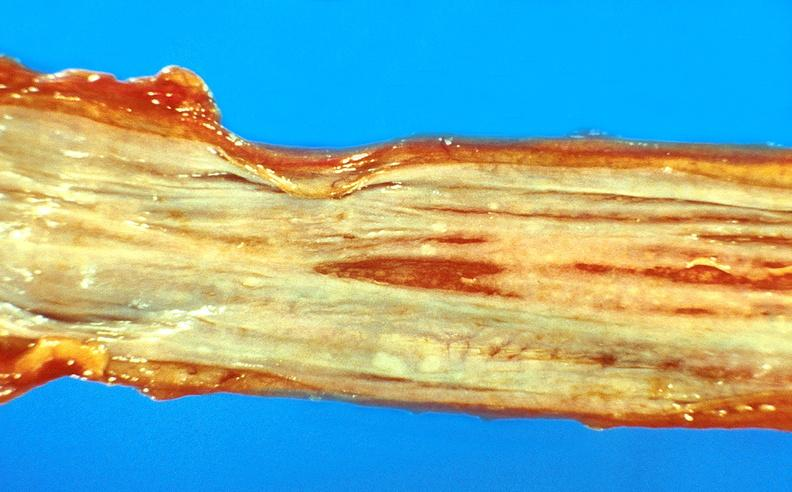s gastrointestinal present?
Answer the question using a single word or phrase. Yes 